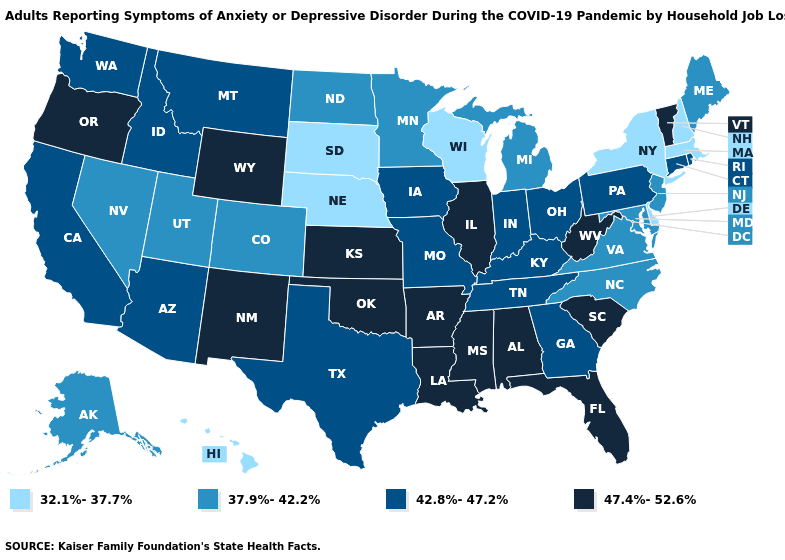What is the highest value in states that border Maine?
Answer briefly. 32.1%-37.7%. What is the highest value in the West ?
Concise answer only. 47.4%-52.6%. What is the value of New Mexico?
Be succinct. 47.4%-52.6%. Is the legend a continuous bar?
Keep it brief. No. What is the highest value in states that border Mississippi?
Answer briefly. 47.4%-52.6%. What is the lowest value in the USA?
Write a very short answer. 32.1%-37.7%. Name the states that have a value in the range 42.8%-47.2%?
Concise answer only. Arizona, California, Connecticut, Georgia, Idaho, Indiana, Iowa, Kentucky, Missouri, Montana, Ohio, Pennsylvania, Rhode Island, Tennessee, Texas, Washington. Name the states that have a value in the range 47.4%-52.6%?
Concise answer only. Alabama, Arkansas, Florida, Illinois, Kansas, Louisiana, Mississippi, New Mexico, Oklahoma, Oregon, South Carolina, Vermont, West Virginia, Wyoming. Name the states that have a value in the range 47.4%-52.6%?
Write a very short answer. Alabama, Arkansas, Florida, Illinois, Kansas, Louisiana, Mississippi, New Mexico, Oklahoma, Oregon, South Carolina, Vermont, West Virginia, Wyoming. Among the states that border Wyoming , which have the lowest value?
Answer briefly. Nebraska, South Dakota. Name the states that have a value in the range 47.4%-52.6%?
Be succinct. Alabama, Arkansas, Florida, Illinois, Kansas, Louisiana, Mississippi, New Mexico, Oklahoma, Oregon, South Carolina, Vermont, West Virginia, Wyoming. Among the states that border Vermont , which have the lowest value?
Give a very brief answer. Massachusetts, New Hampshire, New York. Name the states that have a value in the range 37.9%-42.2%?
Give a very brief answer. Alaska, Colorado, Maine, Maryland, Michigan, Minnesota, Nevada, New Jersey, North Carolina, North Dakota, Utah, Virginia. Among the states that border Oklahoma , does Texas have the highest value?
Give a very brief answer. No. Name the states that have a value in the range 42.8%-47.2%?
Short answer required. Arizona, California, Connecticut, Georgia, Idaho, Indiana, Iowa, Kentucky, Missouri, Montana, Ohio, Pennsylvania, Rhode Island, Tennessee, Texas, Washington. 